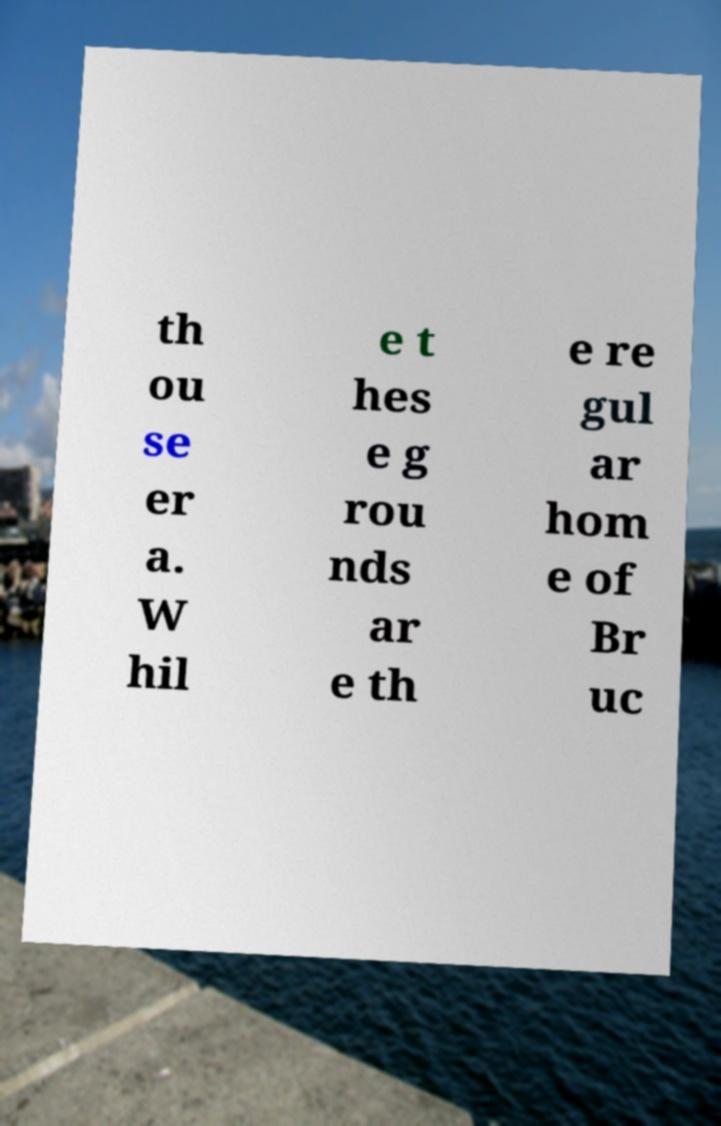Can you read and provide the text displayed in the image?This photo seems to have some interesting text. Can you extract and type it out for me? th ou se er a. W hil e t hes e g rou nds ar e th e re gul ar hom e of Br uc 